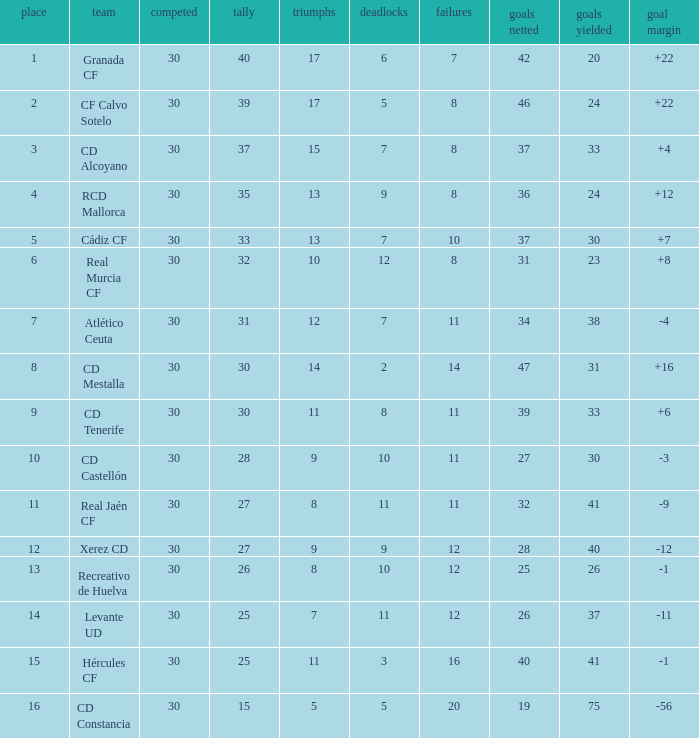Which Played has a Club of atlético ceuta, and less than 11 Losses? None. Can you give me this table as a dict? {'header': ['place', 'team', 'competed', 'tally', 'triumphs', 'deadlocks', 'failures', 'goals netted', 'goals yielded', 'goal margin'], 'rows': [['1', 'Granada CF', '30', '40', '17', '6', '7', '42', '20', '+22'], ['2', 'CF Calvo Sotelo', '30', '39', '17', '5', '8', '46', '24', '+22'], ['3', 'CD Alcoyano', '30', '37', '15', '7', '8', '37', '33', '+4'], ['4', 'RCD Mallorca', '30', '35', '13', '9', '8', '36', '24', '+12'], ['5', 'Cádiz CF', '30', '33', '13', '7', '10', '37', '30', '+7'], ['6', 'Real Murcia CF', '30', '32', '10', '12', '8', '31', '23', '+8'], ['7', 'Atlético Ceuta', '30', '31', '12', '7', '11', '34', '38', '-4'], ['8', 'CD Mestalla', '30', '30', '14', '2', '14', '47', '31', '+16'], ['9', 'CD Tenerife', '30', '30', '11', '8', '11', '39', '33', '+6'], ['10', 'CD Castellón', '30', '28', '9', '10', '11', '27', '30', '-3'], ['11', 'Real Jaén CF', '30', '27', '8', '11', '11', '32', '41', '-9'], ['12', 'Xerez CD', '30', '27', '9', '9', '12', '28', '40', '-12'], ['13', 'Recreativo de Huelva', '30', '26', '8', '10', '12', '25', '26', '-1'], ['14', 'Levante UD', '30', '25', '7', '11', '12', '26', '37', '-11'], ['15', 'Hércules CF', '30', '25', '11', '3', '16', '40', '41', '-1'], ['16', 'CD Constancia', '30', '15', '5', '5', '20', '19', '75', '-56']]} 